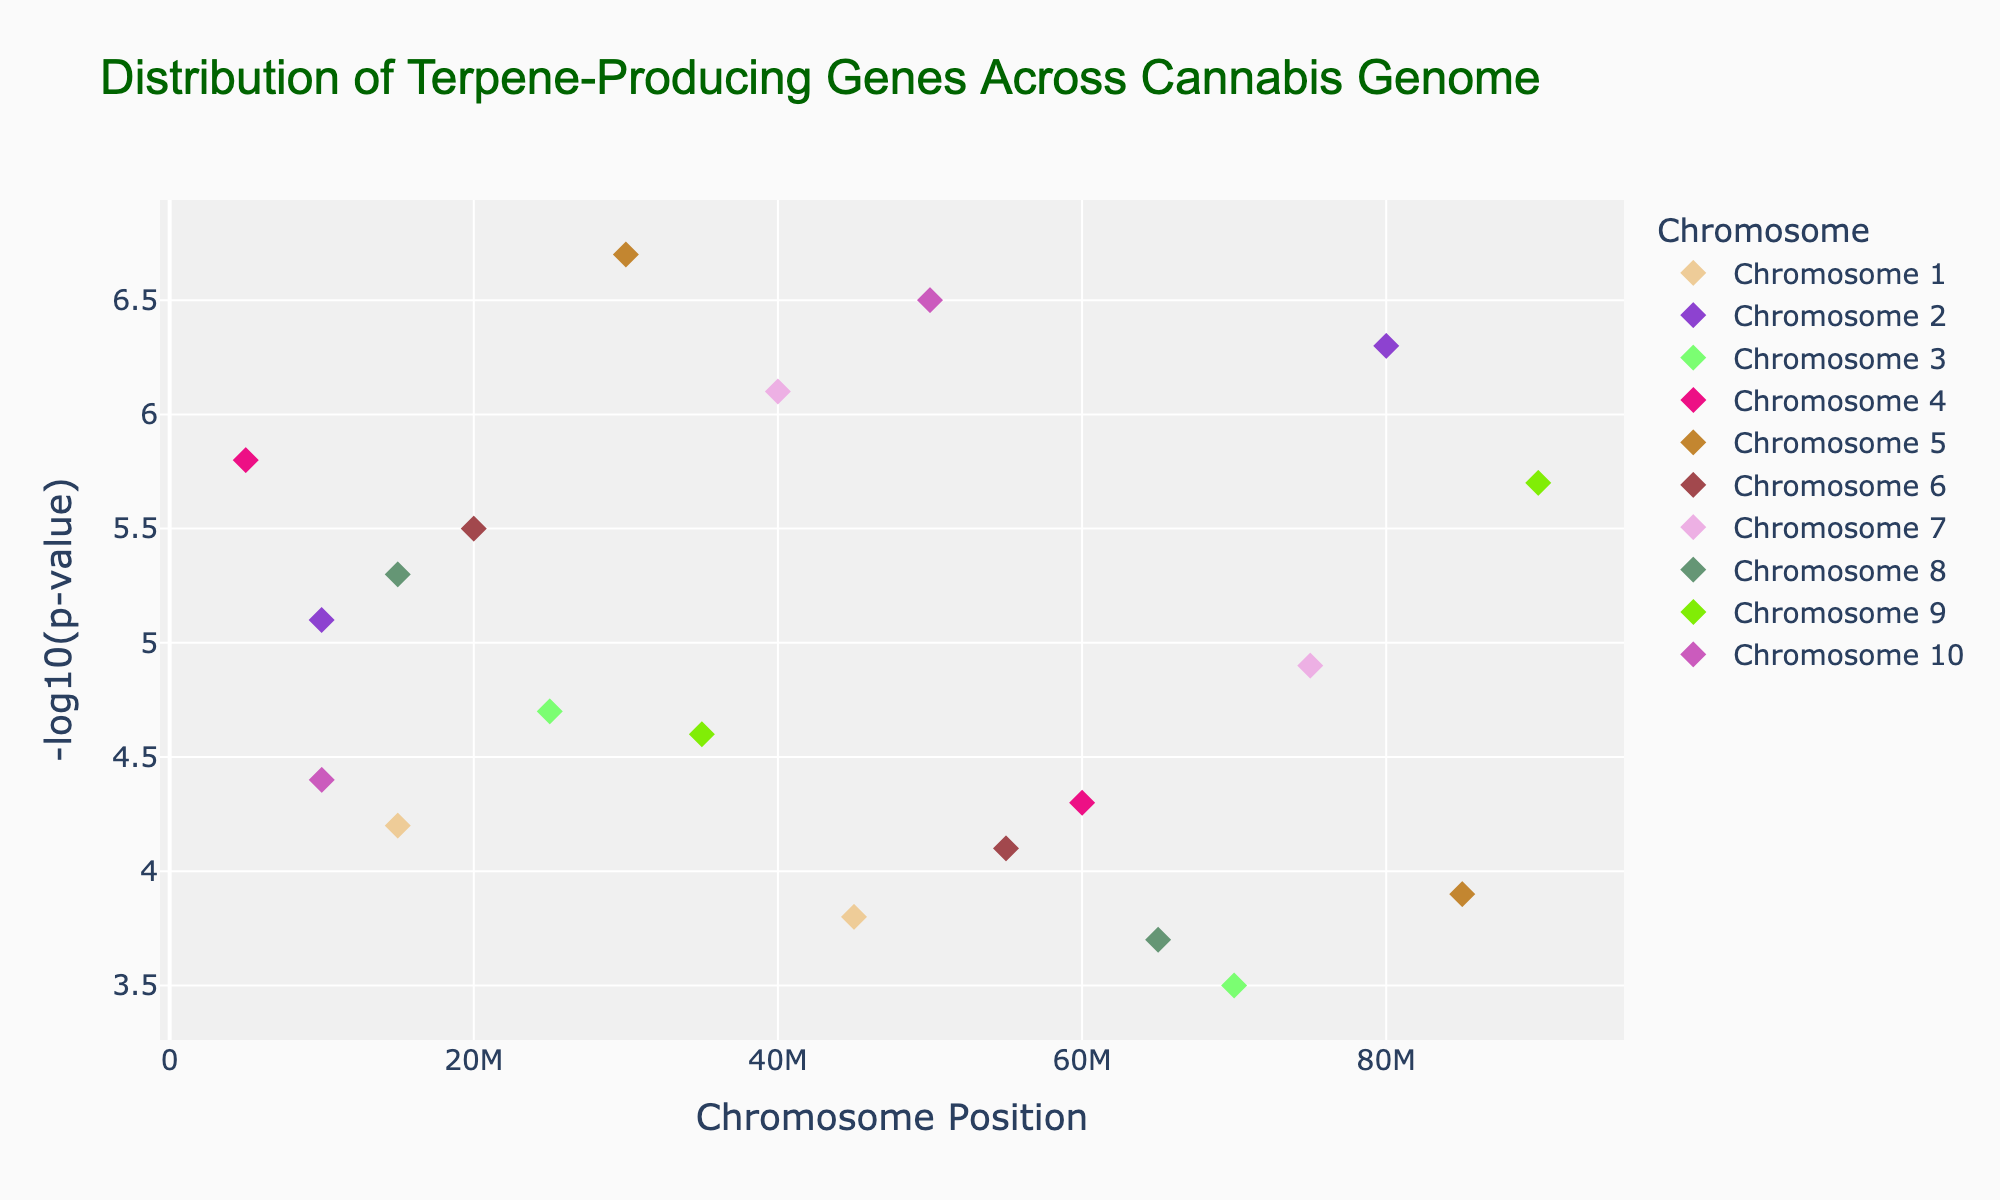What's the title of the plot? The title of the plot is displayed at the top of the figure and gives an overview of the content of the plot.
Answer: Distribution of Terpene-Producing Genes Across Cannabis Genome What does the x-axis represent? The x-axis typically represents some type of position or categorical variable, and in this Manhattan plot, it represents the chromosome positions where the genes are located.
Answer: Chromosome Position How many genes are plotted in Chromosome 5? To determine the number of genes plotted in Chromosome 5, locate Chromosome 5 in the legend and visually count the data points associated with it. Chromosome 5 is represented by two points.
Answer: 2 Which gene has the highest -log10(p-value)? Look for the data point corresponding to the highest value on the y-axis, which represents -log10(p-value). This point represents the gene with the highest -log10(p-value). The gene located at position 30,000,000 in Chromosome 5 achieves the highest value (6.7), and its identity is IPP.
Answer: IPP What range of positions is covered in Chromosome 2? Identify the range of x-values (positions) specifically for Chromosome 2. The points are located at positions 10,000,000 and 80,000,000 in Chromosome 2.
Answer: 10,000,000 to 80,000,000 Which chromosome has the most diverse set of -log10(p-value)? Evaluate the spread in the y-axis values (-log10(p-value)) across different chromosomes. Chromosome 2 and others have distinct points, indicating diversity. However, Chromosome 8 seems more diverse due to the spread from 3.7 to 5.3.
Answer: Chromosome 8 How many data points have a -log10(p-value) greater than 6? Count the markers on the y-axis above the value of 6. There are points at positions 6.3 (Chromosome 2), 6.7 (Chromosome 5), 6.1 (Chromosome 7), and 6.5 (Chromosome 10).
Answer: 4 Which chromosomes display genes with -log10(p-value) less than 4? Look for the data points on the y-axis that fall below the value of 4 and identify their corresponding chromosomes. Chromosomes 1, 3, and 8 have values below 4.
Answer: Chromosomes 1, 3, and 8 What is the color of the points plotted for Chromosome 4? Check the legend or directly find the points plotted for Chromosome 4 in the figure. Observe the color associated with these points visually.
Answer: Various colors (red, blue, etc., as generated randomly; thus, this would be variable based on color mapping) 